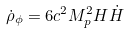<formula> <loc_0><loc_0><loc_500><loc_500>\dot { \rho } _ { \phi } = 6 c ^ { 2 } M _ { p } ^ { 2 } H \dot { H }</formula> 